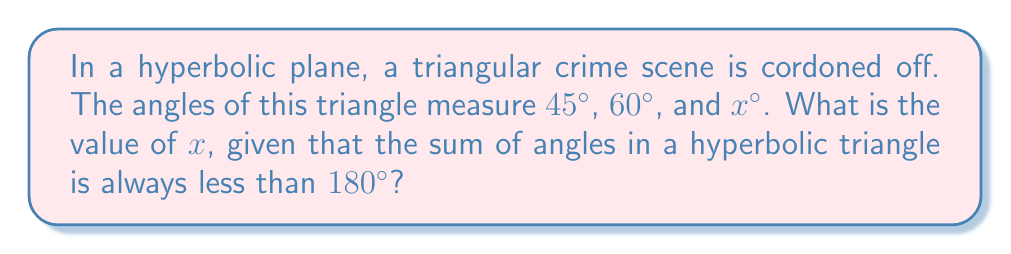Help me with this question. Let's approach this step-by-step:

1) In Euclidean geometry, we know that the sum of angles in a triangle is always $180°$. However, in hyperbolic geometry, this is not the case.

2) In hyperbolic geometry, the sum of angles in a triangle is always less than $180°$. Let's call this sum $S$.

3) We can express this mathematically as:

   $S = 45° + 60° + x° < 180°$

4) Simplifying the left side of the inequality:

   $105° + x° < 180°$

5) Subtracting $105°$ from both sides:

   $x° < 75°$

6) Therefore, $x$ must be less than $75°$.

7) However, we need to find a specific value for $x$. In hyperbolic geometry, the defect (the difference between $180°$ and the sum of angles) is proportional to the area of the triangle.

8) Without more information about the specific hyperbolic plane or the area of the triangle, we can't determine an exact value for $x$.

9) The maximum possible value for $x$ would be just slightly less than $75°$, to ensure the sum remains less than $180°$.
Answer: $x < 75°$ 